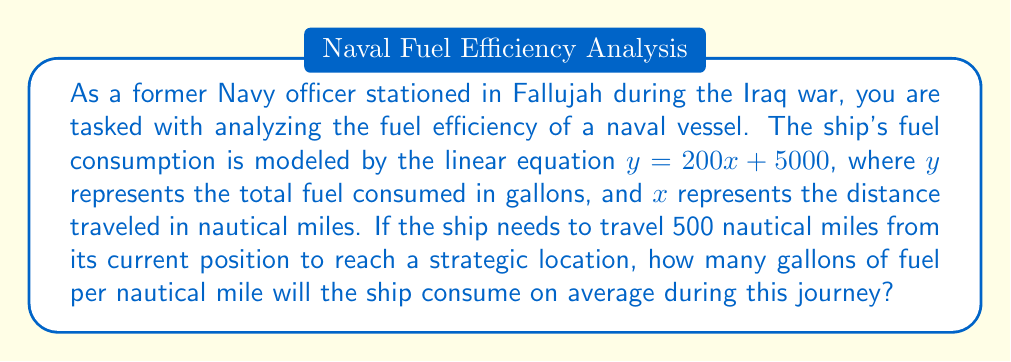Give your solution to this math problem. To solve this problem, we'll follow these steps:

1) First, let's determine the total fuel consumed for the 500 nautical mile journey:
   $$y = 200x + 5000$$
   $$y = 200(500) + 5000$$
   $$y = 100,000 + 5000 = 105,000 \text{ gallons}$$

2) Now, we need to calculate the average fuel consumption per nautical mile:
   Average fuel consumption = Total fuel consumed ÷ Distance traveled
   $$\text{Average fuel consumption} = \frac{105,000 \text{ gallons}}{500 \text{ nautical miles}}$$

3) Simplify the fraction:
   $$\frac{105,000}{500} = 210 \text{ gallons per nautical mile}$$

This result might seem high, but remember that the linear equation includes a constant term (5000 gallons), which represents the fuel needed to start and maintain the ship's systems regardless of distance traveled. This constant fuel usage is averaged over the total distance, increasing the per-mile consumption.
Answer: The ship will consume an average of 210 gallons of fuel per nautical mile during the 500 nautical mile journey. 